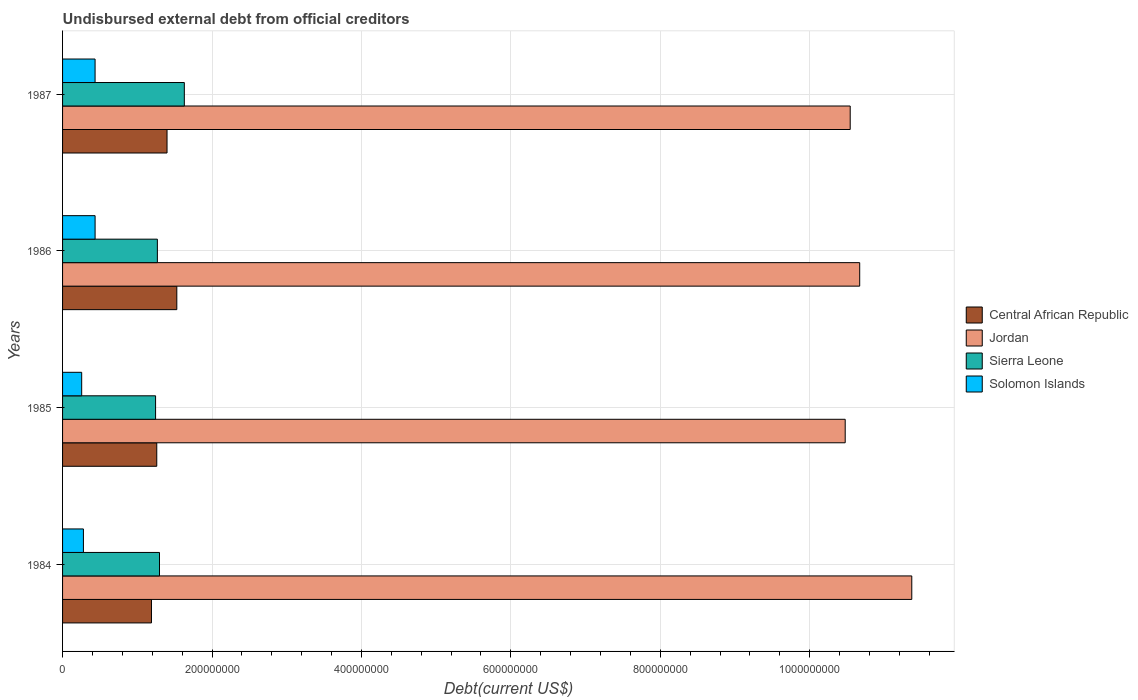Are the number of bars per tick equal to the number of legend labels?
Offer a terse response. Yes. Are the number of bars on each tick of the Y-axis equal?
Make the answer very short. Yes. How many bars are there on the 2nd tick from the top?
Give a very brief answer. 4. How many bars are there on the 2nd tick from the bottom?
Keep it short and to the point. 4. What is the label of the 1st group of bars from the top?
Your answer should be very brief. 1987. What is the total debt in Sierra Leone in 1986?
Your answer should be very brief. 1.27e+08. Across all years, what is the maximum total debt in Solomon Islands?
Ensure brevity in your answer.  4.35e+07. Across all years, what is the minimum total debt in Solomon Islands?
Offer a terse response. 2.56e+07. In which year was the total debt in Solomon Islands minimum?
Ensure brevity in your answer.  1985. What is the total total debt in Solomon Islands in the graph?
Give a very brief answer. 1.41e+08. What is the difference between the total debt in Jordan in 1984 and that in 1986?
Keep it short and to the point. 6.97e+07. What is the difference between the total debt in Central African Republic in 1985 and the total debt in Jordan in 1986?
Your response must be concise. -9.41e+08. What is the average total debt in Central African Republic per year?
Give a very brief answer. 1.34e+08. In the year 1985, what is the difference between the total debt in Solomon Islands and total debt in Jordan?
Offer a very short reply. -1.02e+09. In how many years, is the total debt in Sierra Leone greater than 1040000000 US$?
Your answer should be very brief. 0. What is the ratio of the total debt in Central African Republic in 1985 to that in 1986?
Your answer should be compact. 0.82. Is the difference between the total debt in Solomon Islands in 1984 and 1987 greater than the difference between the total debt in Jordan in 1984 and 1987?
Provide a succinct answer. No. What is the difference between the highest and the second highest total debt in Central African Republic?
Your response must be concise. 1.31e+07. What is the difference between the highest and the lowest total debt in Solomon Islands?
Give a very brief answer. 1.79e+07. Is the sum of the total debt in Central African Republic in 1984 and 1985 greater than the maximum total debt in Solomon Islands across all years?
Your answer should be very brief. Yes. Is it the case that in every year, the sum of the total debt in Sierra Leone and total debt in Central African Republic is greater than the sum of total debt in Jordan and total debt in Solomon Islands?
Make the answer very short. No. What does the 4th bar from the top in 1985 represents?
Offer a very short reply. Central African Republic. What does the 1st bar from the bottom in 1987 represents?
Your response must be concise. Central African Republic. How many years are there in the graph?
Provide a short and direct response. 4. Does the graph contain any zero values?
Keep it short and to the point. No. Does the graph contain grids?
Offer a very short reply. Yes. Where does the legend appear in the graph?
Make the answer very short. Center right. What is the title of the graph?
Make the answer very short. Undisbursed external debt from official creditors. What is the label or title of the X-axis?
Ensure brevity in your answer.  Debt(current US$). What is the Debt(current US$) of Central African Republic in 1984?
Ensure brevity in your answer.  1.19e+08. What is the Debt(current US$) in Jordan in 1984?
Your answer should be very brief. 1.14e+09. What is the Debt(current US$) in Sierra Leone in 1984?
Offer a terse response. 1.30e+08. What is the Debt(current US$) in Solomon Islands in 1984?
Ensure brevity in your answer.  2.79e+07. What is the Debt(current US$) in Central African Republic in 1985?
Make the answer very short. 1.26e+08. What is the Debt(current US$) in Jordan in 1985?
Your answer should be compact. 1.05e+09. What is the Debt(current US$) in Sierra Leone in 1985?
Make the answer very short. 1.24e+08. What is the Debt(current US$) of Solomon Islands in 1985?
Offer a very short reply. 2.56e+07. What is the Debt(current US$) of Central African Republic in 1986?
Give a very brief answer. 1.53e+08. What is the Debt(current US$) in Jordan in 1986?
Ensure brevity in your answer.  1.07e+09. What is the Debt(current US$) in Sierra Leone in 1986?
Give a very brief answer. 1.27e+08. What is the Debt(current US$) in Solomon Islands in 1986?
Your response must be concise. 4.35e+07. What is the Debt(current US$) of Central African Republic in 1987?
Keep it short and to the point. 1.40e+08. What is the Debt(current US$) of Jordan in 1987?
Provide a succinct answer. 1.05e+09. What is the Debt(current US$) of Sierra Leone in 1987?
Keep it short and to the point. 1.63e+08. What is the Debt(current US$) of Solomon Islands in 1987?
Your answer should be compact. 4.35e+07. Across all years, what is the maximum Debt(current US$) in Central African Republic?
Ensure brevity in your answer.  1.53e+08. Across all years, what is the maximum Debt(current US$) in Jordan?
Provide a succinct answer. 1.14e+09. Across all years, what is the maximum Debt(current US$) in Sierra Leone?
Ensure brevity in your answer.  1.63e+08. Across all years, what is the maximum Debt(current US$) of Solomon Islands?
Provide a short and direct response. 4.35e+07. Across all years, what is the minimum Debt(current US$) of Central African Republic?
Your response must be concise. 1.19e+08. Across all years, what is the minimum Debt(current US$) in Jordan?
Give a very brief answer. 1.05e+09. Across all years, what is the minimum Debt(current US$) in Sierra Leone?
Your answer should be very brief. 1.24e+08. Across all years, what is the minimum Debt(current US$) of Solomon Islands?
Provide a short and direct response. 2.56e+07. What is the total Debt(current US$) of Central African Republic in the graph?
Make the answer very short. 5.38e+08. What is the total Debt(current US$) of Jordan in the graph?
Offer a very short reply. 4.31e+09. What is the total Debt(current US$) of Sierra Leone in the graph?
Your answer should be compact. 5.44e+08. What is the total Debt(current US$) of Solomon Islands in the graph?
Keep it short and to the point. 1.41e+08. What is the difference between the Debt(current US$) of Central African Republic in 1984 and that in 1985?
Provide a short and direct response. -7.09e+06. What is the difference between the Debt(current US$) of Jordan in 1984 and that in 1985?
Offer a very short reply. 8.91e+07. What is the difference between the Debt(current US$) of Sierra Leone in 1984 and that in 1985?
Make the answer very short. 5.25e+06. What is the difference between the Debt(current US$) in Solomon Islands in 1984 and that in 1985?
Give a very brief answer. 2.32e+06. What is the difference between the Debt(current US$) of Central African Republic in 1984 and that in 1986?
Make the answer very short. -3.39e+07. What is the difference between the Debt(current US$) in Jordan in 1984 and that in 1986?
Give a very brief answer. 6.97e+07. What is the difference between the Debt(current US$) of Sierra Leone in 1984 and that in 1986?
Your answer should be compact. 2.85e+06. What is the difference between the Debt(current US$) of Solomon Islands in 1984 and that in 1986?
Your response must be concise. -1.56e+07. What is the difference between the Debt(current US$) in Central African Republic in 1984 and that in 1987?
Your answer should be compact. -2.08e+07. What is the difference between the Debt(current US$) of Jordan in 1984 and that in 1987?
Offer a terse response. 8.24e+07. What is the difference between the Debt(current US$) of Sierra Leone in 1984 and that in 1987?
Provide a short and direct response. -3.32e+07. What is the difference between the Debt(current US$) of Solomon Islands in 1984 and that in 1987?
Offer a very short reply. -1.56e+07. What is the difference between the Debt(current US$) of Central African Republic in 1985 and that in 1986?
Your answer should be very brief. -2.68e+07. What is the difference between the Debt(current US$) in Jordan in 1985 and that in 1986?
Your answer should be very brief. -1.94e+07. What is the difference between the Debt(current US$) in Sierra Leone in 1985 and that in 1986?
Keep it short and to the point. -2.40e+06. What is the difference between the Debt(current US$) in Solomon Islands in 1985 and that in 1986?
Your answer should be compact. -1.79e+07. What is the difference between the Debt(current US$) in Central African Republic in 1985 and that in 1987?
Provide a succinct answer. -1.37e+07. What is the difference between the Debt(current US$) of Jordan in 1985 and that in 1987?
Offer a very short reply. -6.70e+06. What is the difference between the Debt(current US$) in Sierra Leone in 1985 and that in 1987?
Make the answer very short. -3.85e+07. What is the difference between the Debt(current US$) of Solomon Islands in 1985 and that in 1987?
Make the answer very short. -1.79e+07. What is the difference between the Debt(current US$) of Central African Republic in 1986 and that in 1987?
Keep it short and to the point. 1.31e+07. What is the difference between the Debt(current US$) of Jordan in 1986 and that in 1987?
Offer a terse response. 1.27e+07. What is the difference between the Debt(current US$) of Sierra Leone in 1986 and that in 1987?
Your response must be concise. -3.61e+07. What is the difference between the Debt(current US$) in Solomon Islands in 1986 and that in 1987?
Make the answer very short. 2.10e+04. What is the difference between the Debt(current US$) of Central African Republic in 1984 and the Debt(current US$) of Jordan in 1985?
Provide a short and direct response. -9.28e+08. What is the difference between the Debt(current US$) in Central African Republic in 1984 and the Debt(current US$) in Sierra Leone in 1985?
Provide a short and direct response. -5.49e+06. What is the difference between the Debt(current US$) in Central African Republic in 1984 and the Debt(current US$) in Solomon Islands in 1985?
Give a very brief answer. 9.34e+07. What is the difference between the Debt(current US$) in Jordan in 1984 and the Debt(current US$) in Sierra Leone in 1985?
Ensure brevity in your answer.  1.01e+09. What is the difference between the Debt(current US$) in Jordan in 1984 and the Debt(current US$) in Solomon Islands in 1985?
Your answer should be very brief. 1.11e+09. What is the difference between the Debt(current US$) in Sierra Leone in 1984 and the Debt(current US$) in Solomon Islands in 1985?
Provide a succinct answer. 1.04e+08. What is the difference between the Debt(current US$) of Central African Republic in 1984 and the Debt(current US$) of Jordan in 1986?
Offer a very short reply. -9.48e+08. What is the difference between the Debt(current US$) of Central African Republic in 1984 and the Debt(current US$) of Sierra Leone in 1986?
Your answer should be very brief. -7.89e+06. What is the difference between the Debt(current US$) of Central African Republic in 1984 and the Debt(current US$) of Solomon Islands in 1986?
Your answer should be compact. 7.55e+07. What is the difference between the Debt(current US$) of Jordan in 1984 and the Debt(current US$) of Sierra Leone in 1986?
Provide a succinct answer. 1.01e+09. What is the difference between the Debt(current US$) in Jordan in 1984 and the Debt(current US$) in Solomon Islands in 1986?
Give a very brief answer. 1.09e+09. What is the difference between the Debt(current US$) in Sierra Leone in 1984 and the Debt(current US$) in Solomon Islands in 1986?
Provide a short and direct response. 8.62e+07. What is the difference between the Debt(current US$) of Central African Republic in 1984 and the Debt(current US$) of Jordan in 1987?
Your response must be concise. -9.35e+08. What is the difference between the Debt(current US$) of Central African Republic in 1984 and the Debt(current US$) of Sierra Leone in 1987?
Your answer should be compact. -4.40e+07. What is the difference between the Debt(current US$) in Central African Republic in 1984 and the Debt(current US$) in Solomon Islands in 1987?
Keep it short and to the point. 7.55e+07. What is the difference between the Debt(current US$) of Jordan in 1984 and the Debt(current US$) of Sierra Leone in 1987?
Your answer should be very brief. 9.74e+08. What is the difference between the Debt(current US$) of Jordan in 1984 and the Debt(current US$) of Solomon Islands in 1987?
Provide a succinct answer. 1.09e+09. What is the difference between the Debt(current US$) of Sierra Leone in 1984 and the Debt(current US$) of Solomon Islands in 1987?
Give a very brief answer. 8.62e+07. What is the difference between the Debt(current US$) in Central African Republic in 1985 and the Debt(current US$) in Jordan in 1986?
Your answer should be very brief. -9.41e+08. What is the difference between the Debt(current US$) in Central African Republic in 1985 and the Debt(current US$) in Sierra Leone in 1986?
Ensure brevity in your answer.  -7.99e+05. What is the difference between the Debt(current US$) of Central African Republic in 1985 and the Debt(current US$) of Solomon Islands in 1986?
Provide a short and direct response. 8.25e+07. What is the difference between the Debt(current US$) in Jordan in 1985 and the Debt(current US$) in Sierra Leone in 1986?
Your response must be concise. 9.21e+08. What is the difference between the Debt(current US$) of Jordan in 1985 and the Debt(current US$) of Solomon Islands in 1986?
Your answer should be compact. 1.00e+09. What is the difference between the Debt(current US$) of Sierra Leone in 1985 and the Debt(current US$) of Solomon Islands in 1986?
Ensure brevity in your answer.  8.09e+07. What is the difference between the Debt(current US$) of Central African Republic in 1985 and the Debt(current US$) of Jordan in 1987?
Your answer should be very brief. -9.28e+08. What is the difference between the Debt(current US$) in Central African Republic in 1985 and the Debt(current US$) in Sierra Leone in 1987?
Keep it short and to the point. -3.69e+07. What is the difference between the Debt(current US$) of Central African Republic in 1985 and the Debt(current US$) of Solomon Islands in 1987?
Keep it short and to the point. 8.26e+07. What is the difference between the Debt(current US$) of Jordan in 1985 and the Debt(current US$) of Sierra Leone in 1987?
Keep it short and to the point. 8.85e+08. What is the difference between the Debt(current US$) of Jordan in 1985 and the Debt(current US$) of Solomon Islands in 1987?
Keep it short and to the point. 1.00e+09. What is the difference between the Debt(current US$) in Sierra Leone in 1985 and the Debt(current US$) in Solomon Islands in 1987?
Provide a succinct answer. 8.10e+07. What is the difference between the Debt(current US$) of Central African Republic in 1986 and the Debt(current US$) of Jordan in 1987?
Keep it short and to the point. -9.01e+08. What is the difference between the Debt(current US$) in Central African Republic in 1986 and the Debt(current US$) in Sierra Leone in 1987?
Offer a very short reply. -1.01e+07. What is the difference between the Debt(current US$) in Central African Republic in 1986 and the Debt(current US$) in Solomon Islands in 1987?
Keep it short and to the point. 1.09e+08. What is the difference between the Debt(current US$) in Jordan in 1986 and the Debt(current US$) in Sierra Leone in 1987?
Make the answer very short. 9.04e+08. What is the difference between the Debt(current US$) in Jordan in 1986 and the Debt(current US$) in Solomon Islands in 1987?
Make the answer very short. 1.02e+09. What is the difference between the Debt(current US$) of Sierra Leone in 1986 and the Debt(current US$) of Solomon Islands in 1987?
Your response must be concise. 8.34e+07. What is the average Debt(current US$) in Central African Republic per year?
Give a very brief answer. 1.34e+08. What is the average Debt(current US$) of Jordan per year?
Give a very brief answer. 1.08e+09. What is the average Debt(current US$) in Sierra Leone per year?
Make the answer very short. 1.36e+08. What is the average Debt(current US$) in Solomon Islands per year?
Provide a succinct answer. 3.51e+07. In the year 1984, what is the difference between the Debt(current US$) of Central African Republic and Debt(current US$) of Jordan?
Give a very brief answer. -1.02e+09. In the year 1984, what is the difference between the Debt(current US$) of Central African Republic and Debt(current US$) of Sierra Leone?
Keep it short and to the point. -1.07e+07. In the year 1984, what is the difference between the Debt(current US$) of Central African Republic and Debt(current US$) of Solomon Islands?
Provide a short and direct response. 9.11e+07. In the year 1984, what is the difference between the Debt(current US$) in Jordan and Debt(current US$) in Sierra Leone?
Your response must be concise. 1.01e+09. In the year 1984, what is the difference between the Debt(current US$) in Jordan and Debt(current US$) in Solomon Islands?
Keep it short and to the point. 1.11e+09. In the year 1984, what is the difference between the Debt(current US$) of Sierra Leone and Debt(current US$) of Solomon Islands?
Provide a short and direct response. 1.02e+08. In the year 1985, what is the difference between the Debt(current US$) of Central African Republic and Debt(current US$) of Jordan?
Make the answer very short. -9.21e+08. In the year 1985, what is the difference between the Debt(current US$) in Central African Republic and Debt(current US$) in Sierra Leone?
Your response must be concise. 1.60e+06. In the year 1985, what is the difference between the Debt(current US$) of Central African Republic and Debt(current US$) of Solomon Islands?
Provide a short and direct response. 1.00e+08. In the year 1985, what is the difference between the Debt(current US$) of Jordan and Debt(current US$) of Sierra Leone?
Provide a succinct answer. 9.23e+08. In the year 1985, what is the difference between the Debt(current US$) in Jordan and Debt(current US$) in Solomon Islands?
Ensure brevity in your answer.  1.02e+09. In the year 1985, what is the difference between the Debt(current US$) of Sierra Leone and Debt(current US$) of Solomon Islands?
Keep it short and to the point. 9.89e+07. In the year 1986, what is the difference between the Debt(current US$) of Central African Republic and Debt(current US$) of Jordan?
Ensure brevity in your answer.  -9.14e+08. In the year 1986, what is the difference between the Debt(current US$) in Central African Republic and Debt(current US$) in Sierra Leone?
Ensure brevity in your answer.  2.60e+07. In the year 1986, what is the difference between the Debt(current US$) of Central African Republic and Debt(current US$) of Solomon Islands?
Offer a terse response. 1.09e+08. In the year 1986, what is the difference between the Debt(current US$) in Jordan and Debt(current US$) in Sierra Leone?
Offer a terse response. 9.40e+08. In the year 1986, what is the difference between the Debt(current US$) in Jordan and Debt(current US$) in Solomon Islands?
Offer a terse response. 1.02e+09. In the year 1986, what is the difference between the Debt(current US$) in Sierra Leone and Debt(current US$) in Solomon Islands?
Your response must be concise. 8.33e+07. In the year 1987, what is the difference between the Debt(current US$) of Central African Republic and Debt(current US$) of Jordan?
Your answer should be compact. -9.14e+08. In the year 1987, what is the difference between the Debt(current US$) in Central African Republic and Debt(current US$) in Sierra Leone?
Offer a very short reply. -2.31e+07. In the year 1987, what is the difference between the Debt(current US$) in Central African Republic and Debt(current US$) in Solomon Islands?
Give a very brief answer. 9.63e+07. In the year 1987, what is the difference between the Debt(current US$) of Jordan and Debt(current US$) of Sierra Leone?
Your answer should be compact. 8.91e+08. In the year 1987, what is the difference between the Debt(current US$) of Jordan and Debt(current US$) of Solomon Islands?
Provide a succinct answer. 1.01e+09. In the year 1987, what is the difference between the Debt(current US$) of Sierra Leone and Debt(current US$) of Solomon Islands?
Provide a succinct answer. 1.19e+08. What is the ratio of the Debt(current US$) of Central African Republic in 1984 to that in 1985?
Your response must be concise. 0.94. What is the ratio of the Debt(current US$) in Jordan in 1984 to that in 1985?
Provide a succinct answer. 1.09. What is the ratio of the Debt(current US$) of Sierra Leone in 1984 to that in 1985?
Your answer should be very brief. 1.04. What is the ratio of the Debt(current US$) in Solomon Islands in 1984 to that in 1985?
Ensure brevity in your answer.  1.09. What is the ratio of the Debt(current US$) in Central African Republic in 1984 to that in 1986?
Provide a short and direct response. 0.78. What is the ratio of the Debt(current US$) in Jordan in 1984 to that in 1986?
Offer a terse response. 1.07. What is the ratio of the Debt(current US$) in Sierra Leone in 1984 to that in 1986?
Make the answer very short. 1.02. What is the ratio of the Debt(current US$) in Solomon Islands in 1984 to that in 1986?
Make the answer very short. 0.64. What is the ratio of the Debt(current US$) of Central African Republic in 1984 to that in 1987?
Offer a terse response. 0.85. What is the ratio of the Debt(current US$) of Jordan in 1984 to that in 1987?
Make the answer very short. 1.08. What is the ratio of the Debt(current US$) of Sierra Leone in 1984 to that in 1987?
Give a very brief answer. 0.8. What is the ratio of the Debt(current US$) in Solomon Islands in 1984 to that in 1987?
Your response must be concise. 0.64. What is the ratio of the Debt(current US$) of Central African Republic in 1985 to that in 1986?
Offer a terse response. 0.82. What is the ratio of the Debt(current US$) of Jordan in 1985 to that in 1986?
Provide a succinct answer. 0.98. What is the ratio of the Debt(current US$) in Sierra Leone in 1985 to that in 1986?
Give a very brief answer. 0.98. What is the ratio of the Debt(current US$) in Solomon Islands in 1985 to that in 1986?
Offer a terse response. 0.59. What is the ratio of the Debt(current US$) of Central African Republic in 1985 to that in 1987?
Make the answer very short. 0.9. What is the ratio of the Debt(current US$) in Jordan in 1985 to that in 1987?
Your response must be concise. 0.99. What is the ratio of the Debt(current US$) of Sierra Leone in 1985 to that in 1987?
Make the answer very short. 0.76. What is the ratio of the Debt(current US$) in Solomon Islands in 1985 to that in 1987?
Provide a short and direct response. 0.59. What is the ratio of the Debt(current US$) of Central African Republic in 1986 to that in 1987?
Your response must be concise. 1.09. What is the ratio of the Debt(current US$) of Sierra Leone in 1986 to that in 1987?
Offer a terse response. 0.78. What is the ratio of the Debt(current US$) in Solomon Islands in 1986 to that in 1987?
Offer a terse response. 1. What is the difference between the highest and the second highest Debt(current US$) of Central African Republic?
Your answer should be compact. 1.31e+07. What is the difference between the highest and the second highest Debt(current US$) of Jordan?
Give a very brief answer. 6.97e+07. What is the difference between the highest and the second highest Debt(current US$) in Sierra Leone?
Offer a very short reply. 3.32e+07. What is the difference between the highest and the second highest Debt(current US$) in Solomon Islands?
Give a very brief answer. 2.10e+04. What is the difference between the highest and the lowest Debt(current US$) in Central African Republic?
Provide a succinct answer. 3.39e+07. What is the difference between the highest and the lowest Debt(current US$) of Jordan?
Your answer should be very brief. 8.91e+07. What is the difference between the highest and the lowest Debt(current US$) of Sierra Leone?
Offer a very short reply. 3.85e+07. What is the difference between the highest and the lowest Debt(current US$) in Solomon Islands?
Keep it short and to the point. 1.79e+07. 